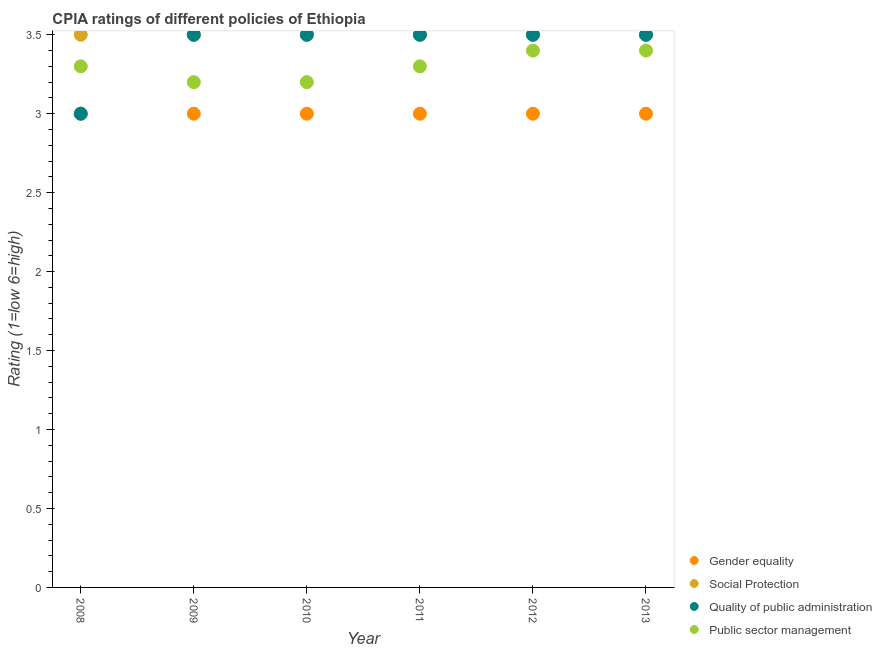How many different coloured dotlines are there?
Keep it short and to the point. 4. Is the number of dotlines equal to the number of legend labels?
Offer a very short reply. Yes. In which year was the cpia rating of quality of public administration minimum?
Keep it short and to the point. 2008. What is the total cpia rating of public sector management in the graph?
Make the answer very short. 19.8. What is the difference between the cpia rating of social protection in 2012 and that in 2013?
Your response must be concise. 0. What is the average cpia rating of public sector management per year?
Offer a very short reply. 3.3. In the year 2013, what is the difference between the cpia rating of public sector management and cpia rating of social protection?
Make the answer very short. -0.1. In how many years, is the cpia rating of social protection greater than 1.4?
Provide a succinct answer. 6. What is the difference between the highest and the second highest cpia rating of gender equality?
Ensure brevity in your answer.  0. What is the difference between the highest and the lowest cpia rating of social protection?
Offer a very short reply. 0. Is the sum of the cpia rating of quality of public administration in 2008 and 2013 greater than the maximum cpia rating of social protection across all years?
Provide a succinct answer. Yes. Does the cpia rating of gender equality monotonically increase over the years?
Give a very brief answer. No. How many years are there in the graph?
Offer a very short reply. 6. Are the values on the major ticks of Y-axis written in scientific E-notation?
Offer a terse response. No. Does the graph contain any zero values?
Provide a short and direct response. No. Does the graph contain grids?
Keep it short and to the point. No. How many legend labels are there?
Offer a terse response. 4. How are the legend labels stacked?
Offer a terse response. Vertical. What is the title of the graph?
Make the answer very short. CPIA ratings of different policies of Ethiopia. What is the label or title of the Y-axis?
Provide a succinct answer. Rating (1=low 6=high). What is the Rating (1=low 6=high) of Quality of public administration in 2008?
Your answer should be very brief. 3. What is the Rating (1=low 6=high) in Gender equality in 2009?
Provide a succinct answer. 3. What is the Rating (1=low 6=high) in Quality of public administration in 2009?
Make the answer very short. 3.5. What is the Rating (1=low 6=high) in Gender equality in 2010?
Offer a very short reply. 3. What is the Rating (1=low 6=high) in Social Protection in 2010?
Make the answer very short. 3.5. What is the Rating (1=low 6=high) of Public sector management in 2010?
Your answer should be very brief. 3.2. What is the Rating (1=low 6=high) of Quality of public administration in 2011?
Your response must be concise. 3.5. What is the Rating (1=low 6=high) in Public sector management in 2011?
Provide a succinct answer. 3.3. What is the Rating (1=low 6=high) in Gender equality in 2012?
Offer a very short reply. 3. What is the Rating (1=low 6=high) in Quality of public administration in 2012?
Offer a terse response. 3.5. What is the Rating (1=low 6=high) in Public sector management in 2012?
Ensure brevity in your answer.  3.4. What is the Rating (1=low 6=high) of Quality of public administration in 2013?
Your answer should be very brief. 3.5. What is the Rating (1=low 6=high) in Public sector management in 2013?
Offer a terse response. 3.4. Across all years, what is the maximum Rating (1=low 6=high) of Public sector management?
Give a very brief answer. 3.4. Across all years, what is the minimum Rating (1=low 6=high) in Gender equality?
Your answer should be very brief. 3. Across all years, what is the minimum Rating (1=low 6=high) in Social Protection?
Your answer should be compact. 3.5. Across all years, what is the minimum Rating (1=low 6=high) in Quality of public administration?
Ensure brevity in your answer.  3. Across all years, what is the minimum Rating (1=low 6=high) of Public sector management?
Offer a terse response. 3.2. What is the total Rating (1=low 6=high) in Quality of public administration in the graph?
Your response must be concise. 20.5. What is the total Rating (1=low 6=high) in Public sector management in the graph?
Give a very brief answer. 19.8. What is the difference between the Rating (1=low 6=high) in Social Protection in 2008 and that in 2009?
Ensure brevity in your answer.  0. What is the difference between the Rating (1=low 6=high) in Quality of public administration in 2008 and that in 2009?
Provide a succinct answer. -0.5. What is the difference between the Rating (1=low 6=high) of Gender equality in 2008 and that in 2010?
Offer a terse response. 0. What is the difference between the Rating (1=low 6=high) in Gender equality in 2008 and that in 2011?
Provide a succinct answer. 0. What is the difference between the Rating (1=low 6=high) in Quality of public administration in 2008 and that in 2012?
Ensure brevity in your answer.  -0.5. What is the difference between the Rating (1=low 6=high) of Public sector management in 2008 and that in 2012?
Give a very brief answer. -0.1. What is the difference between the Rating (1=low 6=high) in Gender equality in 2008 and that in 2013?
Provide a short and direct response. 0. What is the difference between the Rating (1=low 6=high) of Social Protection in 2008 and that in 2013?
Offer a terse response. 0. What is the difference between the Rating (1=low 6=high) in Quality of public administration in 2008 and that in 2013?
Make the answer very short. -0.5. What is the difference between the Rating (1=low 6=high) of Social Protection in 2009 and that in 2010?
Offer a very short reply. 0. What is the difference between the Rating (1=low 6=high) in Quality of public administration in 2009 and that in 2010?
Your response must be concise. 0. What is the difference between the Rating (1=low 6=high) of Gender equality in 2009 and that in 2011?
Provide a succinct answer. 0. What is the difference between the Rating (1=low 6=high) of Social Protection in 2009 and that in 2011?
Keep it short and to the point. 0. What is the difference between the Rating (1=low 6=high) of Public sector management in 2009 and that in 2011?
Provide a succinct answer. -0.1. What is the difference between the Rating (1=low 6=high) in Social Protection in 2009 and that in 2012?
Make the answer very short. 0. What is the difference between the Rating (1=low 6=high) of Quality of public administration in 2009 and that in 2012?
Keep it short and to the point. 0. What is the difference between the Rating (1=low 6=high) in Public sector management in 2009 and that in 2012?
Provide a succinct answer. -0.2. What is the difference between the Rating (1=low 6=high) in Social Protection in 2009 and that in 2013?
Give a very brief answer. 0. What is the difference between the Rating (1=low 6=high) in Quality of public administration in 2009 and that in 2013?
Your answer should be very brief. 0. What is the difference between the Rating (1=low 6=high) in Gender equality in 2010 and that in 2011?
Your response must be concise. 0. What is the difference between the Rating (1=low 6=high) of Social Protection in 2010 and that in 2011?
Your response must be concise. 0. What is the difference between the Rating (1=low 6=high) of Quality of public administration in 2010 and that in 2011?
Provide a succinct answer. 0. What is the difference between the Rating (1=low 6=high) in Public sector management in 2010 and that in 2011?
Provide a succinct answer. -0.1. What is the difference between the Rating (1=low 6=high) of Gender equality in 2010 and that in 2013?
Your response must be concise. 0. What is the difference between the Rating (1=low 6=high) in Social Protection in 2010 and that in 2013?
Keep it short and to the point. 0. What is the difference between the Rating (1=low 6=high) in Quality of public administration in 2010 and that in 2013?
Give a very brief answer. 0. What is the difference between the Rating (1=low 6=high) of Gender equality in 2011 and that in 2012?
Offer a terse response. 0. What is the difference between the Rating (1=low 6=high) of Social Protection in 2011 and that in 2012?
Provide a succinct answer. 0. What is the difference between the Rating (1=low 6=high) of Social Protection in 2011 and that in 2013?
Your response must be concise. 0. What is the difference between the Rating (1=low 6=high) in Quality of public administration in 2011 and that in 2013?
Your response must be concise. 0. What is the difference between the Rating (1=low 6=high) of Quality of public administration in 2012 and that in 2013?
Keep it short and to the point. 0. What is the difference between the Rating (1=low 6=high) of Public sector management in 2012 and that in 2013?
Ensure brevity in your answer.  0. What is the difference between the Rating (1=low 6=high) of Social Protection in 2008 and the Rating (1=low 6=high) of Quality of public administration in 2009?
Offer a terse response. 0. What is the difference between the Rating (1=low 6=high) of Quality of public administration in 2008 and the Rating (1=low 6=high) of Public sector management in 2009?
Keep it short and to the point. -0.2. What is the difference between the Rating (1=low 6=high) in Gender equality in 2008 and the Rating (1=low 6=high) in Quality of public administration in 2010?
Make the answer very short. -0.5. What is the difference between the Rating (1=low 6=high) of Social Protection in 2008 and the Rating (1=low 6=high) of Quality of public administration in 2010?
Make the answer very short. 0. What is the difference between the Rating (1=low 6=high) of Gender equality in 2008 and the Rating (1=low 6=high) of Social Protection in 2011?
Your answer should be very brief. -0.5. What is the difference between the Rating (1=low 6=high) in Social Protection in 2008 and the Rating (1=low 6=high) in Quality of public administration in 2011?
Your answer should be very brief. 0. What is the difference between the Rating (1=low 6=high) in Gender equality in 2008 and the Rating (1=low 6=high) in Social Protection in 2012?
Your answer should be compact. -0.5. What is the difference between the Rating (1=low 6=high) in Gender equality in 2008 and the Rating (1=low 6=high) in Quality of public administration in 2012?
Make the answer very short. -0.5. What is the difference between the Rating (1=low 6=high) of Social Protection in 2008 and the Rating (1=low 6=high) of Quality of public administration in 2012?
Give a very brief answer. 0. What is the difference between the Rating (1=low 6=high) of Social Protection in 2008 and the Rating (1=low 6=high) of Public sector management in 2012?
Provide a short and direct response. 0.1. What is the difference between the Rating (1=low 6=high) in Quality of public administration in 2008 and the Rating (1=low 6=high) in Public sector management in 2012?
Offer a very short reply. -0.4. What is the difference between the Rating (1=low 6=high) of Gender equality in 2008 and the Rating (1=low 6=high) of Quality of public administration in 2013?
Your response must be concise. -0.5. What is the difference between the Rating (1=low 6=high) in Gender equality in 2008 and the Rating (1=low 6=high) in Public sector management in 2013?
Offer a very short reply. -0.4. What is the difference between the Rating (1=low 6=high) of Social Protection in 2008 and the Rating (1=low 6=high) of Quality of public administration in 2013?
Offer a very short reply. 0. What is the difference between the Rating (1=low 6=high) of Social Protection in 2008 and the Rating (1=low 6=high) of Public sector management in 2013?
Keep it short and to the point. 0.1. What is the difference between the Rating (1=low 6=high) of Quality of public administration in 2008 and the Rating (1=low 6=high) of Public sector management in 2013?
Keep it short and to the point. -0.4. What is the difference between the Rating (1=low 6=high) of Gender equality in 2009 and the Rating (1=low 6=high) of Public sector management in 2010?
Offer a very short reply. -0.2. What is the difference between the Rating (1=low 6=high) of Social Protection in 2009 and the Rating (1=low 6=high) of Public sector management in 2010?
Provide a succinct answer. 0.3. What is the difference between the Rating (1=low 6=high) of Quality of public administration in 2009 and the Rating (1=low 6=high) of Public sector management in 2010?
Offer a very short reply. 0.3. What is the difference between the Rating (1=low 6=high) of Gender equality in 2009 and the Rating (1=low 6=high) of Social Protection in 2011?
Your answer should be compact. -0.5. What is the difference between the Rating (1=low 6=high) of Gender equality in 2009 and the Rating (1=low 6=high) of Quality of public administration in 2011?
Give a very brief answer. -0.5. What is the difference between the Rating (1=low 6=high) of Social Protection in 2009 and the Rating (1=low 6=high) of Public sector management in 2011?
Make the answer very short. 0.2. What is the difference between the Rating (1=low 6=high) in Gender equality in 2009 and the Rating (1=low 6=high) in Social Protection in 2012?
Offer a very short reply. -0.5. What is the difference between the Rating (1=low 6=high) in Gender equality in 2009 and the Rating (1=low 6=high) in Public sector management in 2012?
Offer a very short reply. -0.4. What is the difference between the Rating (1=low 6=high) of Social Protection in 2009 and the Rating (1=low 6=high) of Public sector management in 2012?
Your response must be concise. 0.1. What is the difference between the Rating (1=low 6=high) of Quality of public administration in 2009 and the Rating (1=low 6=high) of Public sector management in 2012?
Your response must be concise. 0.1. What is the difference between the Rating (1=low 6=high) in Gender equality in 2009 and the Rating (1=low 6=high) in Public sector management in 2013?
Keep it short and to the point. -0.4. What is the difference between the Rating (1=low 6=high) of Social Protection in 2009 and the Rating (1=low 6=high) of Quality of public administration in 2013?
Your response must be concise. 0. What is the difference between the Rating (1=low 6=high) in Quality of public administration in 2009 and the Rating (1=low 6=high) in Public sector management in 2013?
Your response must be concise. 0.1. What is the difference between the Rating (1=low 6=high) of Gender equality in 2010 and the Rating (1=low 6=high) of Quality of public administration in 2011?
Your answer should be compact. -0.5. What is the difference between the Rating (1=low 6=high) in Gender equality in 2010 and the Rating (1=low 6=high) in Public sector management in 2011?
Provide a succinct answer. -0.3. What is the difference between the Rating (1=low 6=high) of Quality of public administration in 2010 and the Rating (1=low 6=high) of Public sector management in 2011?
Offer a terse response. 0.2. What is the difference between the Rating (1=low 6=high) in Gender equality in 2010 and the Rating (1=low 6=high) in Social Protection in 2012?
Provide a short and direct response. -0.5. What is the difference between the Rating (1=low 6=high) of Gender equality in 2010 and the Rating (1=low 6=high) of Public sector management in 2012?
Make the answer very short. -0.4. What is the difference between the Rating (1=low 6=high) of Social Protection in 2010 and the Rating (1=low 6=high) of Quality of public administration in 2012?
Offer a very short reply. 0. What is the difference between the Rating (1=low 6=high) of Quality of public administration in 2010 and the Rating (1=low 6=high) of Public sector management in 2012?
Offer a very short reply. 0.1. What is the difference between the Rating (1=low 6=high) of Gender equality in 2010 and the Rating (1=low 6=high) of Quality of public administration in 2013?
Make the answer very short. -0.5. What is the difference between the Rating (1=low 6=high) in Social Protection in 2010 and the Rating (1=low 6=high) in Quality of public administration in 2013?
Ensure brevity in your answer.  0. What is the difference between the Rating (1=low 6=high) of Social Protection in 2010 and the Rating (1=low 6=high) of Public sector management in 2013?
Your answer should be very brief. 0.1. What is the difference between the Rating (1=low 6=high) in Gender equality in 2011 and the Rating (1=low 6=high) in Quality of public administration in 2012?
Ensure brevity in your answer.  -0.5. What is the difference between the Rating (1=low 6=high) in Gender equality in 2011 and the Rating (1=low 6=high) in Quality of public administration in 2013?
Give a very brief answer. -0.5. What is the difference between the Rating (1=low 6=high) in Gender equality in 2011 and the Rating (1=low 6=high) in Public sector management in 2013?
Your response must be concise. -0.4. What is the difference between the Rating (1=low 6=high) of Gender equality in 2012 and the Rating (1=low 6=high) of Quality of public administration in 2013?
Make the answer very short. -0.5. What is the difference between the Rating (1=low 6=high) of Gender equality in 2012 and the Rating (1=low 6=high) of Public sector management in 2013?
Your answer should be compact. -0.4. What is the difference between the Rating (1=low 6=high) in Quality of public administration in 2012 and the Rating (1=low 6=high) in Public sector management in 2013?
Ensure brevity in your answer.  0.1. What is the average Rating (1=low 6=high) of Gender equality per year?
Make the answer very short. 3. What is the average Rating (1=low 6=high) in Social Protection per year?
Keep it short and to the point. 3.5. What is the average Rating (1=low 6=high) in Quality of public administration per year?
Your answer should be very brief. 3.42. What is the average Rating (1=low 6=high) of Public sector management per year?
Your answer should be compact. 3.3. In the year 2008, what is the difference between the Rating (1=low 6=high) of Gender equality and Rating (1=low 6=high) of Social Protection?
Make the answer very short. -0.5. In the year 2008, what is the difference between the Rating (1=low 6=high) of Social Protection and Rating (1=low 6=high) of Quality of public administration?
Offer a very short reply. 0.5. In the year 2008, what is the difference between the Rating (1=low 6=high) of Quality of public administration and Rating (1=low 6=high) of Public sector management?
Offer a very short reply. -0.3. In the year 2009, what is the difference between the Rating (1=low 6=high) in Quality of public administration and Rating (1=low 6=high) in Public sector management?
Give a very brief answer. 0.3. In the year 2010, what is the difference between the Rating (1=low 6=high) of Gender equality and Rating (1=low 6=high) of Quality of public administration?
Provide a succinct answer. -0.5. In the year 2010, what is the difference between the Rating (1=low 6=high) of Social Protection and Rating (1=low 6=high) of Public sector management?
Your answer should be compact. 0.3. In the year 2010, what is the difference between the Rating (1=low 6=high) of Quality of public administration and Rating (1=low 6=high) of Public sector management?
Provide a short and direct response. 0.3. In the year 2011, what is the difference between the Rating (1=low 6=high) of Gender equality and Rating (1=low 6=high) of Quality of public administration?
Provide a short and direct response. -0.5. In the year 2011, what is the difference between the Rating (1=low 6=high) of Social Protection and Rating (1=low 6=high) of Quality of public administration?
Provide a succinct answer. 0. In the year 2011, what is the difference between the Rating (1=low 6=high) of Quality of public administration and Rating (1=low 6=high) of Public sector management?
Make the answer very short. 0.2. In the year 2012, what is the difference between the Rating (1=low 6=high) of Social Protection and Rating (1=low 6=high) of Quality of public administration?
Your answer should be very brief. 0. In the year 2012, what is the difference between the Rating (1=low 6=high) in Quality of public administration and Rating (1=low 6=high) in Public sector management?
Give a very brief answer. 0.1. In the year 2013, what is the difference between the Rating (1=low 6=high) in Gender equality and Rating (1=low 6=high) in Quality of public administration?
Your answer should be very brief. -0.5. In the year 2013, what is the difference between the Rating (1=low 6=high) in Gender equality and Rating (1=low 6=high) in Public sector management?
Make the answer very short. -0.4. In the year 2013, what is the difference between the Rating (1=low 6=high) of Social Protection and Rating (1=low 6=high) of Quality of public administration?
Give a very brief answer. 0. In the year 2013, what is the difference between the Rating (1=low 6=high) in Social Protection and Rating (1=low 6=high) in Public sector management?
Ensure brevity in your answer.  0.1. What is the ratio of the Rating (1=low 6=high) in Gender equality in 2008 to that in 2009?
Keep it short and to the point. 1. What is the ratio of the Rating (1=low 6=high) in Public sector management in 2008 to that in 2009?
Provide a succinct answer. 1.03. What is the ratio of the Rating (1=low 6=high) in Social Protection in 2008 to that in 2010?
Your response must be concise. 1. What is the ratio of the Rating (1=low 6=high) of Quality of public administration in 2008 to that in 2010?
Ensure brevity in your answer.  0.86. What is the ratio of the Rating (1=low 6=high) in Public sector management in 2008 to that in 2010?
Offer a very short reply. 1.03. What is the ratio of the Rating (1=low 6=high) of Social Protection in 2008 to that in 2011?
Offer a very short reply. 1. What is the ratio of the Rating (1=low 6=high) in Social Protection in 2008 to that in 2012?
Provide a short and direct response. 1. What is the ratio of the Rating (1=low 6=high) of Quality of public administration in 2008 to that in 2012?
Ensure brevity in your answer.  0.86. What is the ratio of the Rating (1=low 6=high) in Public sector management in 2008 to that in 2012?
Offer a terse response. 0.97. What is the ratio of the Rating (1=low 6=high) of Gender equality in 2008 to that in 2013?
Keep it short and to the point. 1. What is the ratio of the Rating (1=low 6=high) in Social Protection in 2008 to that in 2013?
Your answer should be compact. 1. What is the ratio of the Rating (1=low 6=high) in Quality of public administration in 2008 to that in 2013?
Provide a succinct answer. 0.86. What is the ratio of the Rating (1=low 6=high) of Public sector management in 2008 to that in 2013?
Provide a succinct answer. 0.97. What is the ratio of the Rating (1=low 6=high) of Gender equality in 2009 to that in 2010?
Offer a very short reply. 1. What is the ratio of the Rating (1=low 6=high) of Public sector management in 2009 to that in 2010?
Provide a short and direct response. 1. What is the ratio of the Rating (1=low 6=high) in Quality of public administration in 2009 to that in 2011?
Your response must be concise. 1. What is the ratio of the Rating (1=low 6=high) in Public sector management in 2009 to that in 2011?
Ensure brevity in your answer.  0.97. What is the ratio of the Rating (1=low 6=high) in Gender equality in 2009 to that in 2012?
Offer a very short reply. 1. What is the ratio of the Rating (1=low 6=high) in Social Protection in 2009 to that in 2013?
Make the answer very short. 1. What is the ratio of the Rating (1=low 6=high) of Social Protection in 2010 to that in 2011?
Offer a terse response. 1. What is the ratio of the Rating (1=low 6=high) in Quality of public administration in 2010 to that in 2011?
Ensure brevity in your answer.  1. What is the ratio of the Rating (1=low 6=high) of Public sector management in 2010 to that in 2011?
Ensure brevity in your answer.  0.97. What is the ratio of the Rating (1=low 6=high) of Gender equality in 2010 to that in 2012?
Your answer should be very brief. 1. What is the ratio of the Rating (1=low 6=high) in Quality of public administration in 2010 to that in 2012?
Provide a short and direct response. 1. What is the ratio of the Rating (1=low 6=high) in Gender equality in 2010 to that in 2013?
Ensure brevity in your answer.  1. What is the ratio of the Rating (1=low 6=high) of Quality of public administration in 2010 to that in 2013?
Keep it short and to the point. 1. What is the ratio of the Rating (1=low 6=high) in Quality of public administration in 2011 to that in 2012?
Offer a terse response. 1. What is the ratio of the Rating (1=low 6=high) in Public sector management in 2011 to that in 2012?
Offer a very short reply. 0.97. What is the ratio of the Rating (1=low 6=high) of Social Protection in 2011 to that in 2013?
Give a very brief answer. 1. What is the ratio of the Rating (1=low 6=high) of Quality of public administration in 2011 to that in 2013?
Your answer should be very brief. 1. What is the ratio of the Rating (1=low 6=high) in Public sector management in 2011 to that in 2013?
Keep it short and to the point. 0.97. What is the ratio of the Rating (1=low 6=high) of Gender equality in 2012 to that in 2013?
Your answer should be very brief. 1. What is the ratio of the Rating (1=low 6=high) in Social Protection in 2012 to that in 2013?
Offer a terse response. 1. What is the ratio of the Rating (1=low 6=high) of Quality of public administration in 2012 to that in 2013?
Give a very brief answer. 1. What is the ratio of the Rating (1=low 6=high) of Public sector management in 2012 to that in 2013?
Offer a very short reply. 1. What is the difference between the highest and the second highest Rating (1=low 6=high) of Public sector management?
Keep it short and to the point. 0. What is the difference between the highest and the lowest Rating (1=low 6=high) of Social Protection?
Keep it short and to the point. 0. What is the difference between the highest and the lowest Rating (1=low 6=high) in Public sector management?
Make the answer very short. 0.2. 